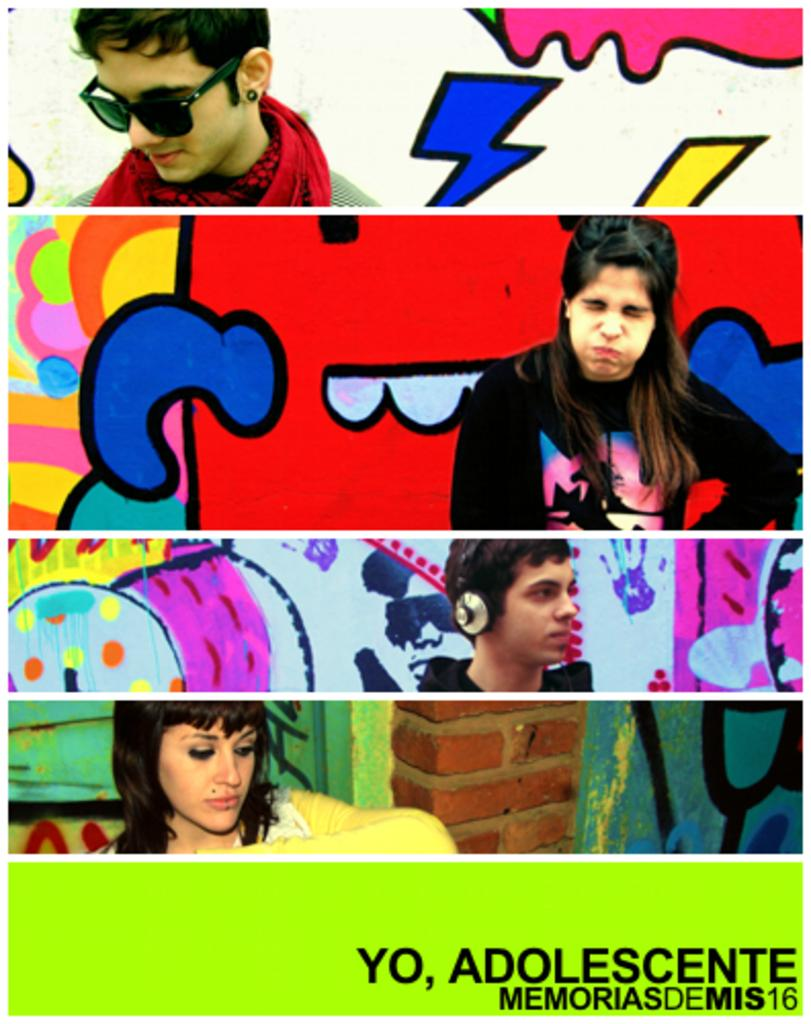How many photographs are visible in the image? There are four photographs in the image. What subjects are depicted in the photographs? Two of the photographs depict men, and two depict women. Where are the people in the photographs standing? The people in the photographs are standing near a painted wall. What language are the people in the photographs speaking? The image does not provide any information about the language being spoken by the people in the photographs. How many feet are visible in the image? There are no feet visible in the image, as the focus is on the photographs and the people in them. 